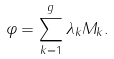<formula> <loc_0><loc_0><loc_500><loc_500>\varphi = \sum _ { k = 1 } ^ { g } \lambda _ { k } M _ { k } .</formula> 